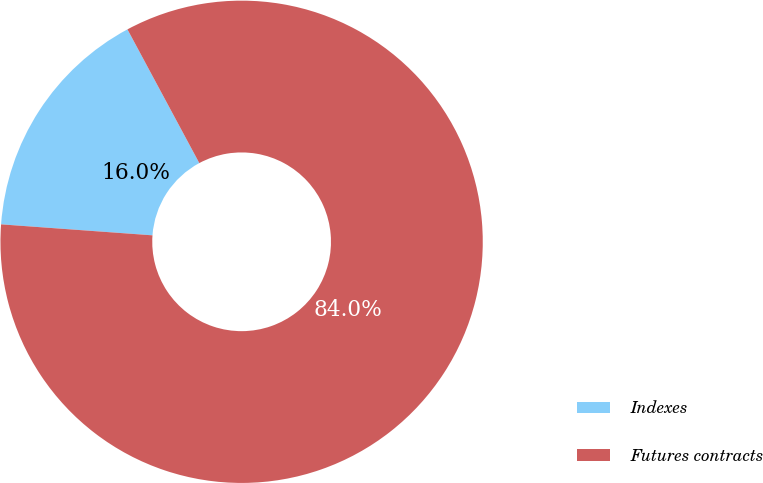Convert chart to OTSL. <chart><loc_0><loc_0><loc_500><loc_500><pie_chart><fcel>Indexes<fcel>Futures contracts<nl><fcel>16.0%<fcel>84.0%<nl></chart> 